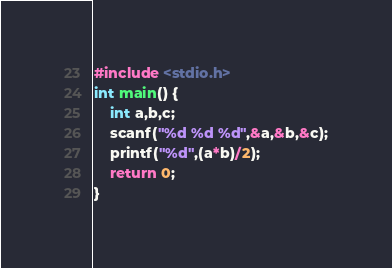<code> <loc_0><loc_0><loc_500><loc_500><_C++_>#include <stdio.h>
int main() {
	int a,b,c;
	scanf("%d %d %d",&a,&b,&c);
	printf("%d",(a*b)/2);
	return 0;
}</code> 